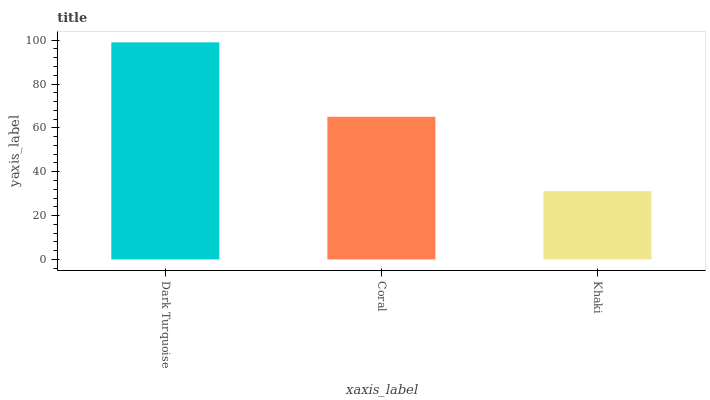Is Khaki the minimum?
Answer yes or no. Yes. Is Dark Turquoise the maximum?
Answer yes or no. Yes. Is Coral the minimum?
Answer yes or no. No. Is Coral the maximum?
Answer yes or no. No. Is Dark Turquoise greater than Coral?
Answer yes or no. Yes. Is Coral less than Dark Turquoise?
Answer yes or no. Yes. Is Coral greater than Dark Turquoise?
Answer yes or no. No. Is Dark Turquoise less than Coral?
Answer yes or no. No. Is Coral the high median?
Answer yes or no. Yes. Is Coral the low median?
Answer yes or no. Yes. Is Dark Turquoise the high median?
Answer yes or no. No. Is Khaki the low median?
Answer yes or no. No. 